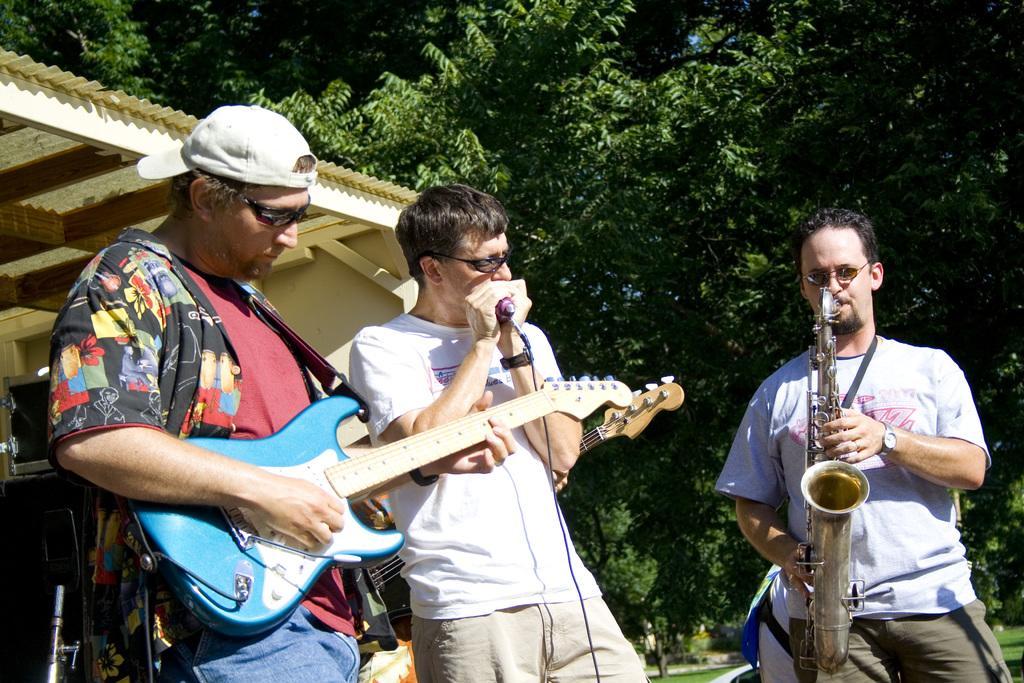Describe this image in one or two sentences. In this picture we can see three men playing musical instruments. On the background we can see trees. 